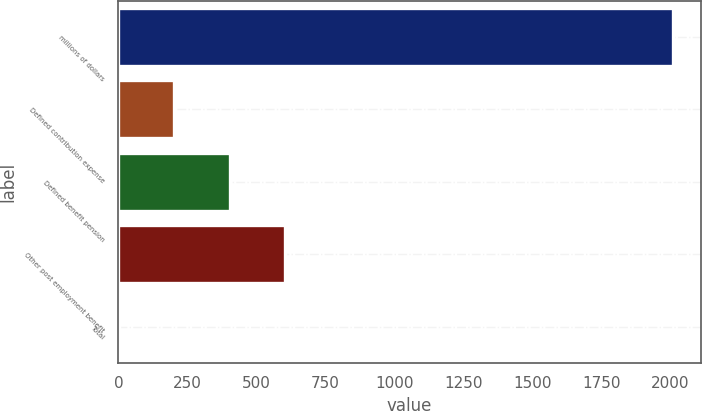<chart> <loc_0><loc_0><loc_500><loc_500><bar_chart><fcel>millions of dollars<fcel>Defined contribution expense<fcel>Defined benefit pension<fcel>Other post employment benefit<fcel>Total<nl><fcel>2009<fcel>202.07<fcel>402.84<fcel>603.61<fcel>1.3<nl></chart> 